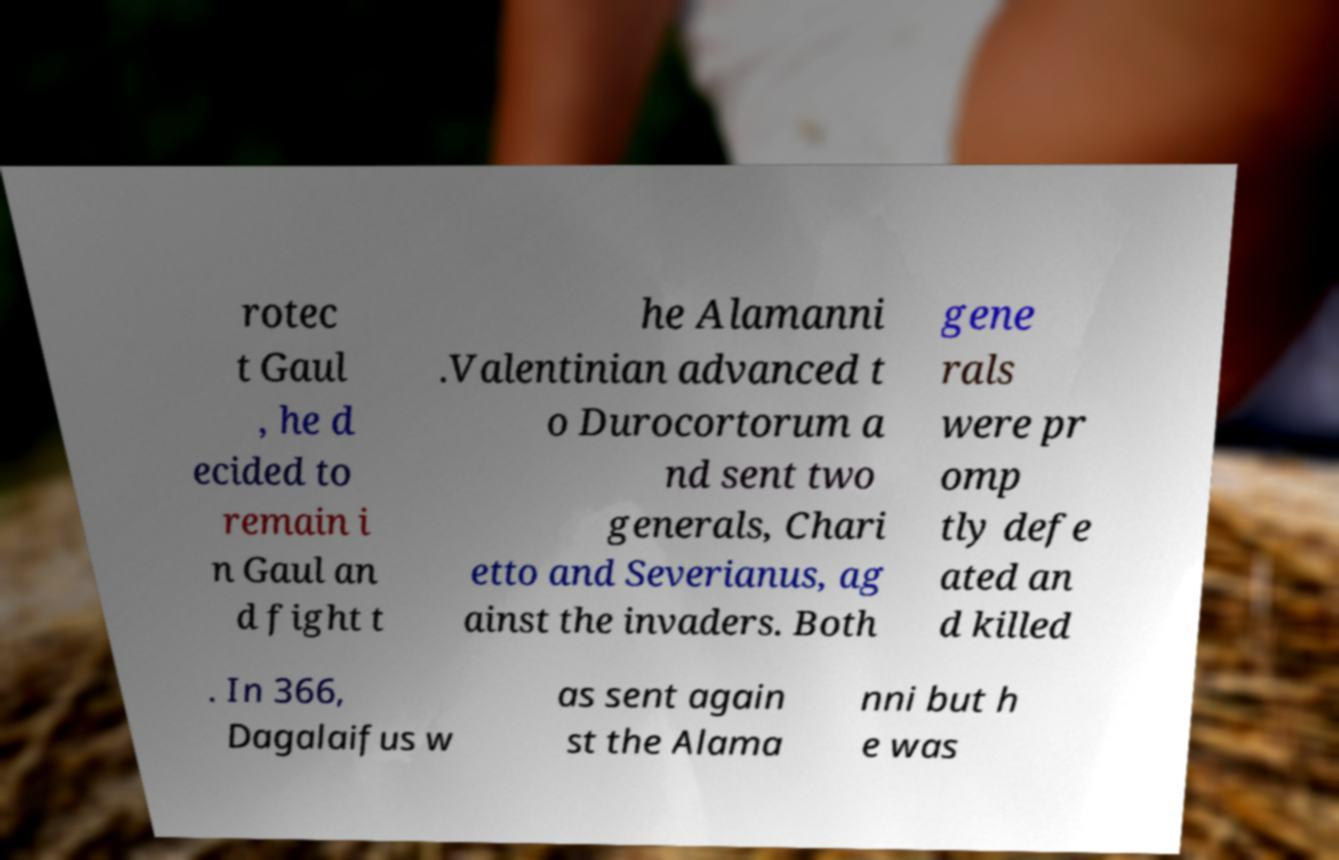Can you read and provide the text displayed in the image?This photo seems to have some interesting text. Can you extract and type it out for me? rotec t Gaul , he d ecided to remain i n Gaul an d fight t he Alamanni .Valentinian advanced t o Durocortorum a nd sent two generals, Chari etto and Severianus, ag ainst the invaders. Both gene rals were pr omp tly defe ated an d killed . In 366, Dagalaifus w as sent again st the Alama nni but h e was 